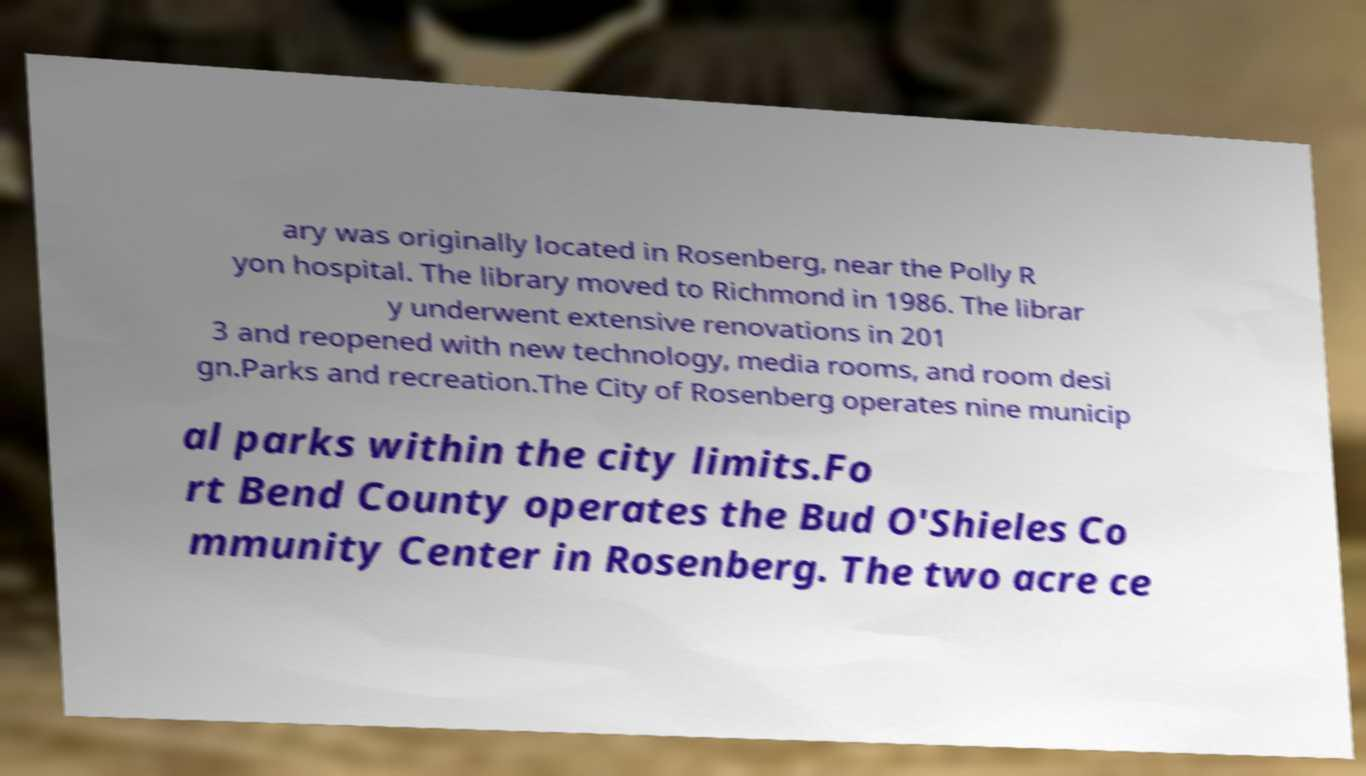Could you extract and type out the text from this image? ary was originally located in Rosenberg, near the Polly R yon hospital. The library moved to Richmond in 1986. The librar y underwent extensive renovations in 201 3 and reopened with new technology, media rooms, and room desi gn.Parks and recreation.The City of Rosenberg operates nine municip al parks within the city limits.Fo rt Bend County operates the Bud O'Shieles Co mmunity Center in Rosenberg. The two acre ce 